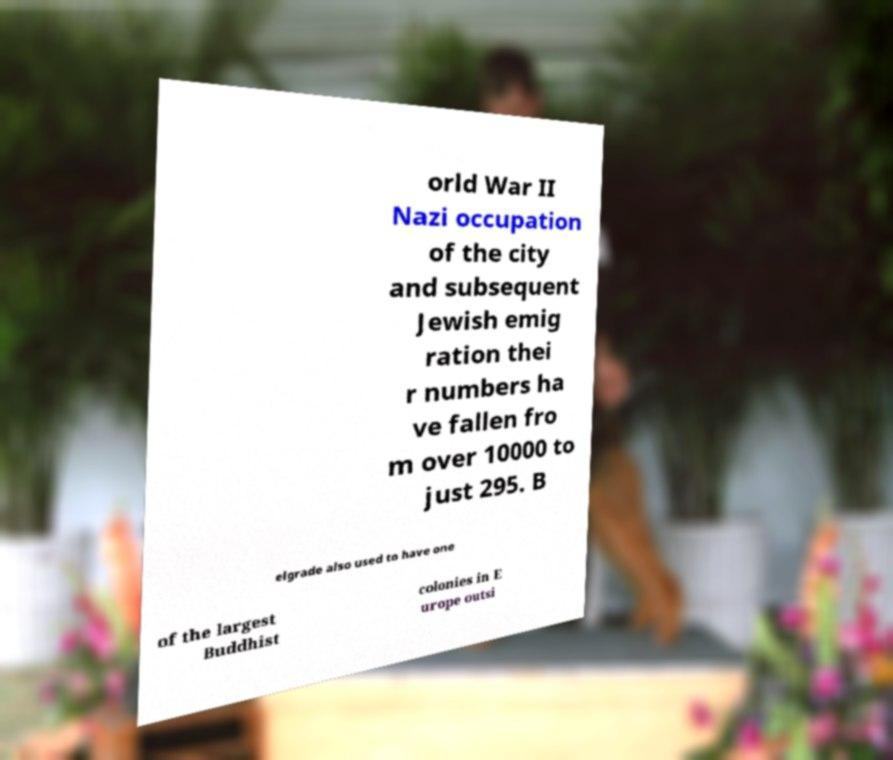What messages or text are displayed in this image? I need them in a readable, typed format. orld War II Nazi occupation of the city and subsequent Jewish emig ration thei r numbers ha ve fallen fro m over 10000 to just 295. B elgrade also used to have one of the largest Buddhist colonies in E urope outsi 